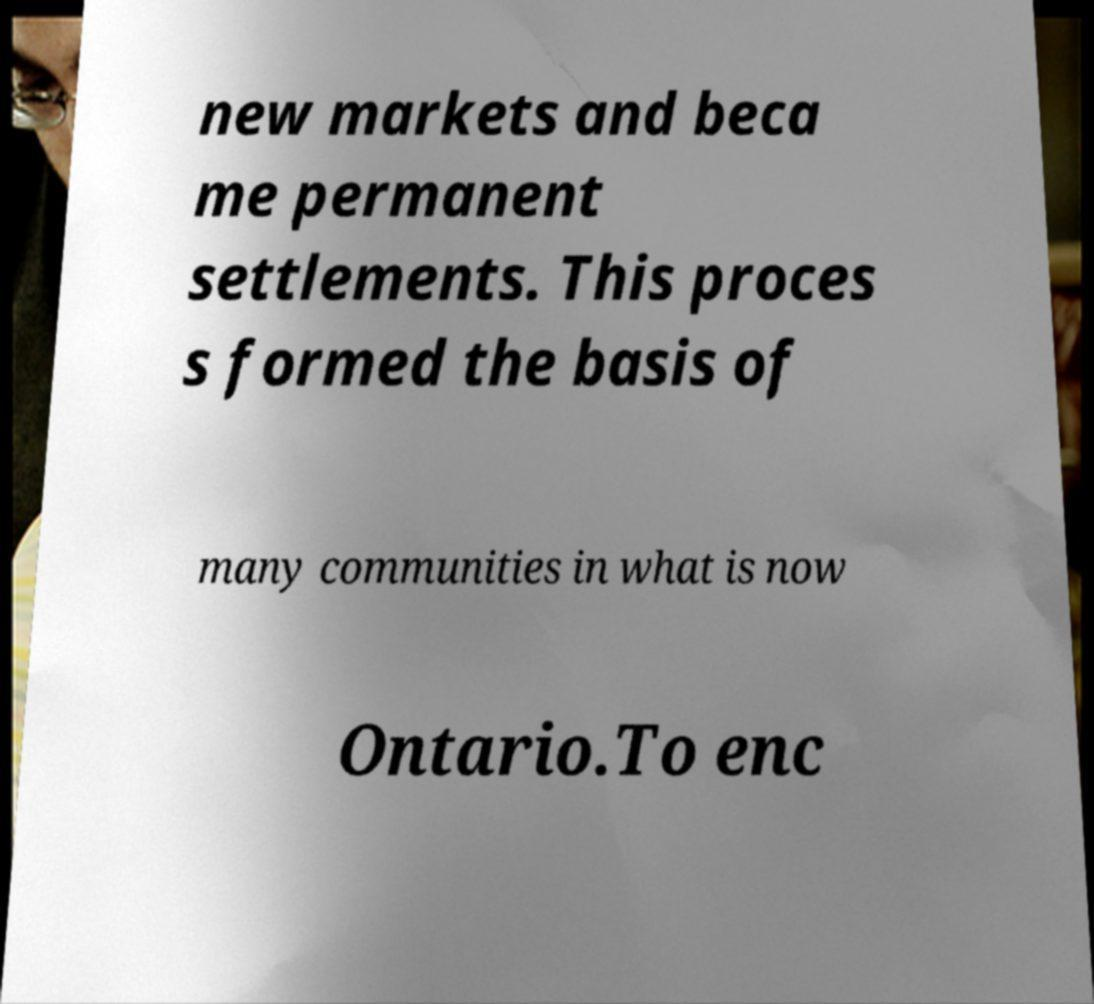Can you accurately transcribe the text from the provided image for me? new markets and beca me permanent settlements. This proces s formed the basis of many communities in what is now Ontario.To enc 